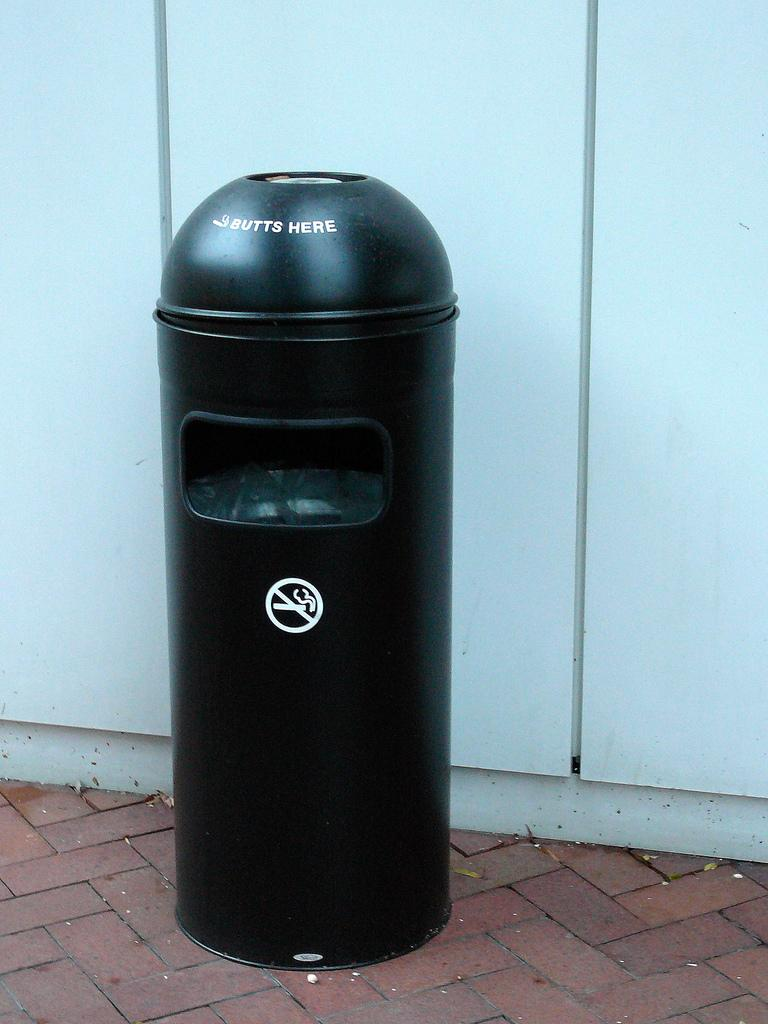Provide a one-sentence caption for the provided image. A black trash can with the sign on it that says "butts here". 